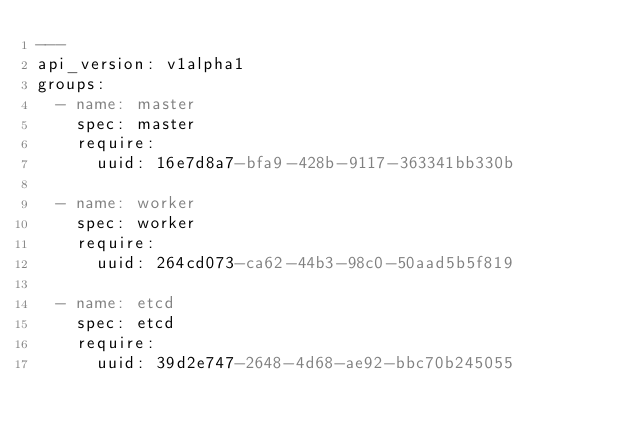Convert code to text. <code><loc_0><loc_0><loc_500><loc_500><_YAML_>---
api_version: v1alpha1
groups:
  - name: master
    spec: master
    require:
      uuid: 16e7d8a7-bfa9-428b-9117-363341bb330b

  - name: worker
    spec: worker
    require:
      uuid: 264cd073-ca62-44b3-98c0-50aad5b5f819

  - name: etcd
    spec: etcd
    require:
      uuid: 39d2e747-2648-4d68-ae92-bbc70b245055

</code> 